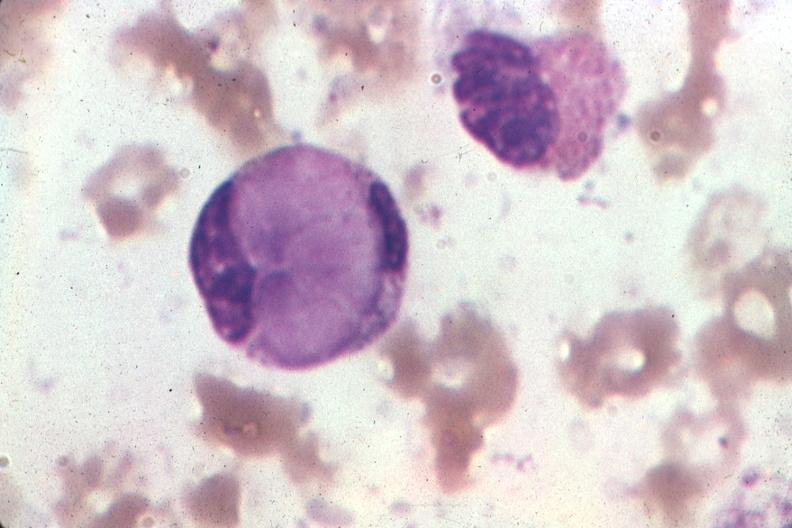s von present?
Answer the question using a single word or phrase. No 